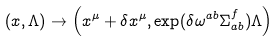<formula> <loc_0><loc_0><loc_500><loc_500>\left ( x , \Lambda \right ) \rightarrow \left ( x ^ { \mu } + \delta x ^ { \mu } , \exp ( \delta \omega ^ { a b } \Sigma _ { a b } ^ { f } ) \Lambda \right )</formula> 